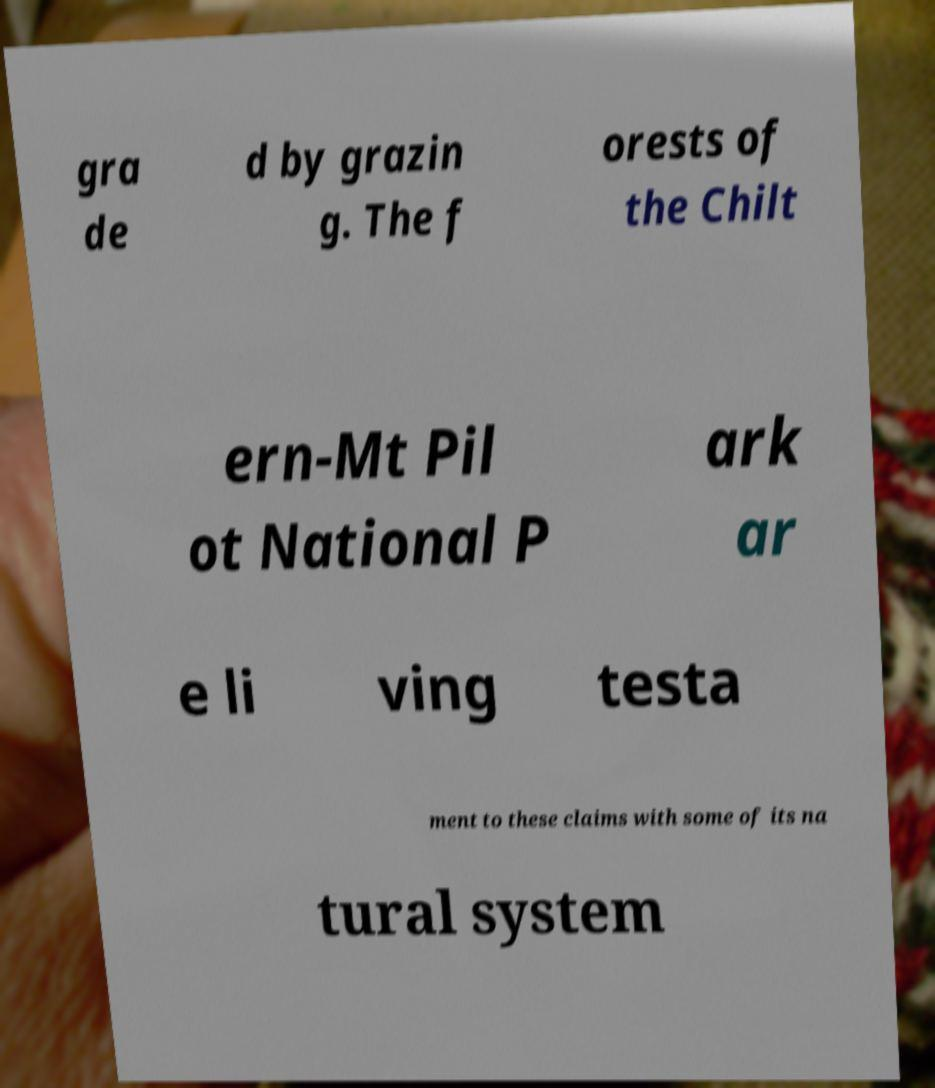Please read and relay the text visible in this image. What does it say? gra de d by grazin g. The f orests of the Chilt ern-Mt Pil ot National P ark ar e li ving testa ment to these claims with some of its na tural system 